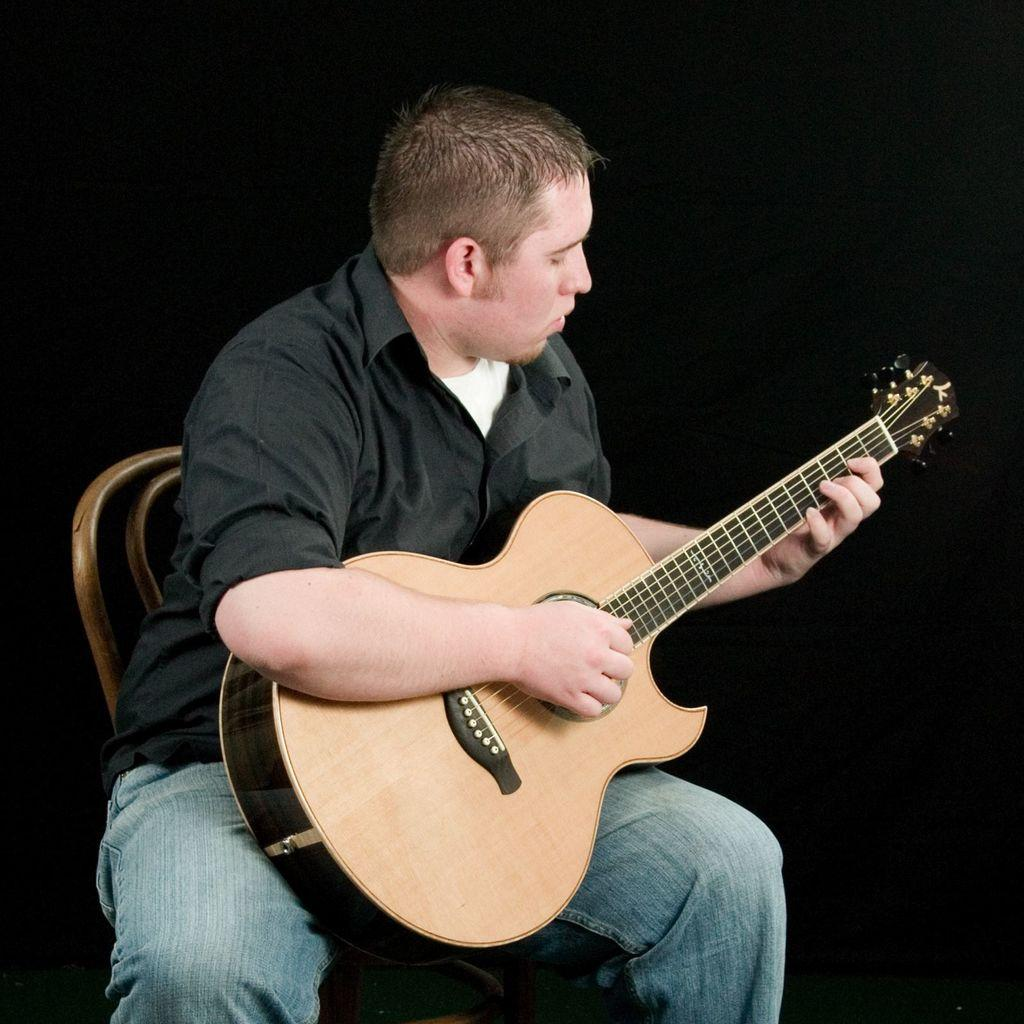Who is the main subject in the image? There is a man in the image. What is the man doing in the image? The man is playing a guitar. What is the man sitting on in the image? The man is sitting on a chair. What type of minister is present in the image? There is no minister present in the image; it features a man playing a guitar while sitting on a chair. 